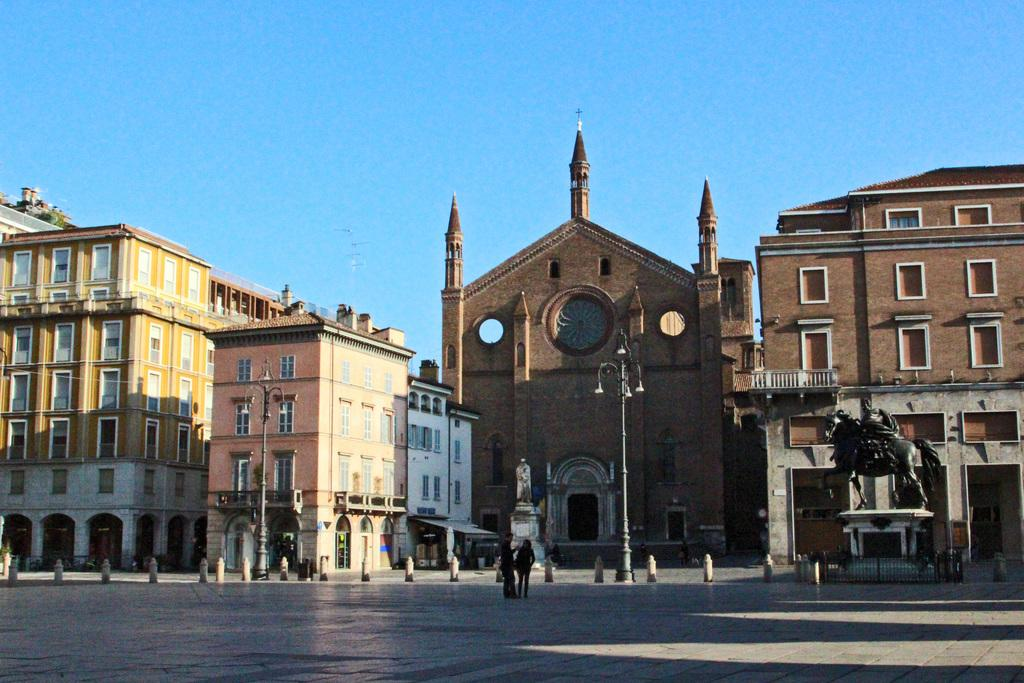What type of structures can be seen in the image? There are buildings in the image. What is located in front of the buildings? There are statues in front of the buildings. What else can be seen in the image besides buildings and statues? There are poles in the image. Are there any living beings present in the image? Yes, there are people in the image. Where are the toys stored in the image? There are no toys present in the image. 